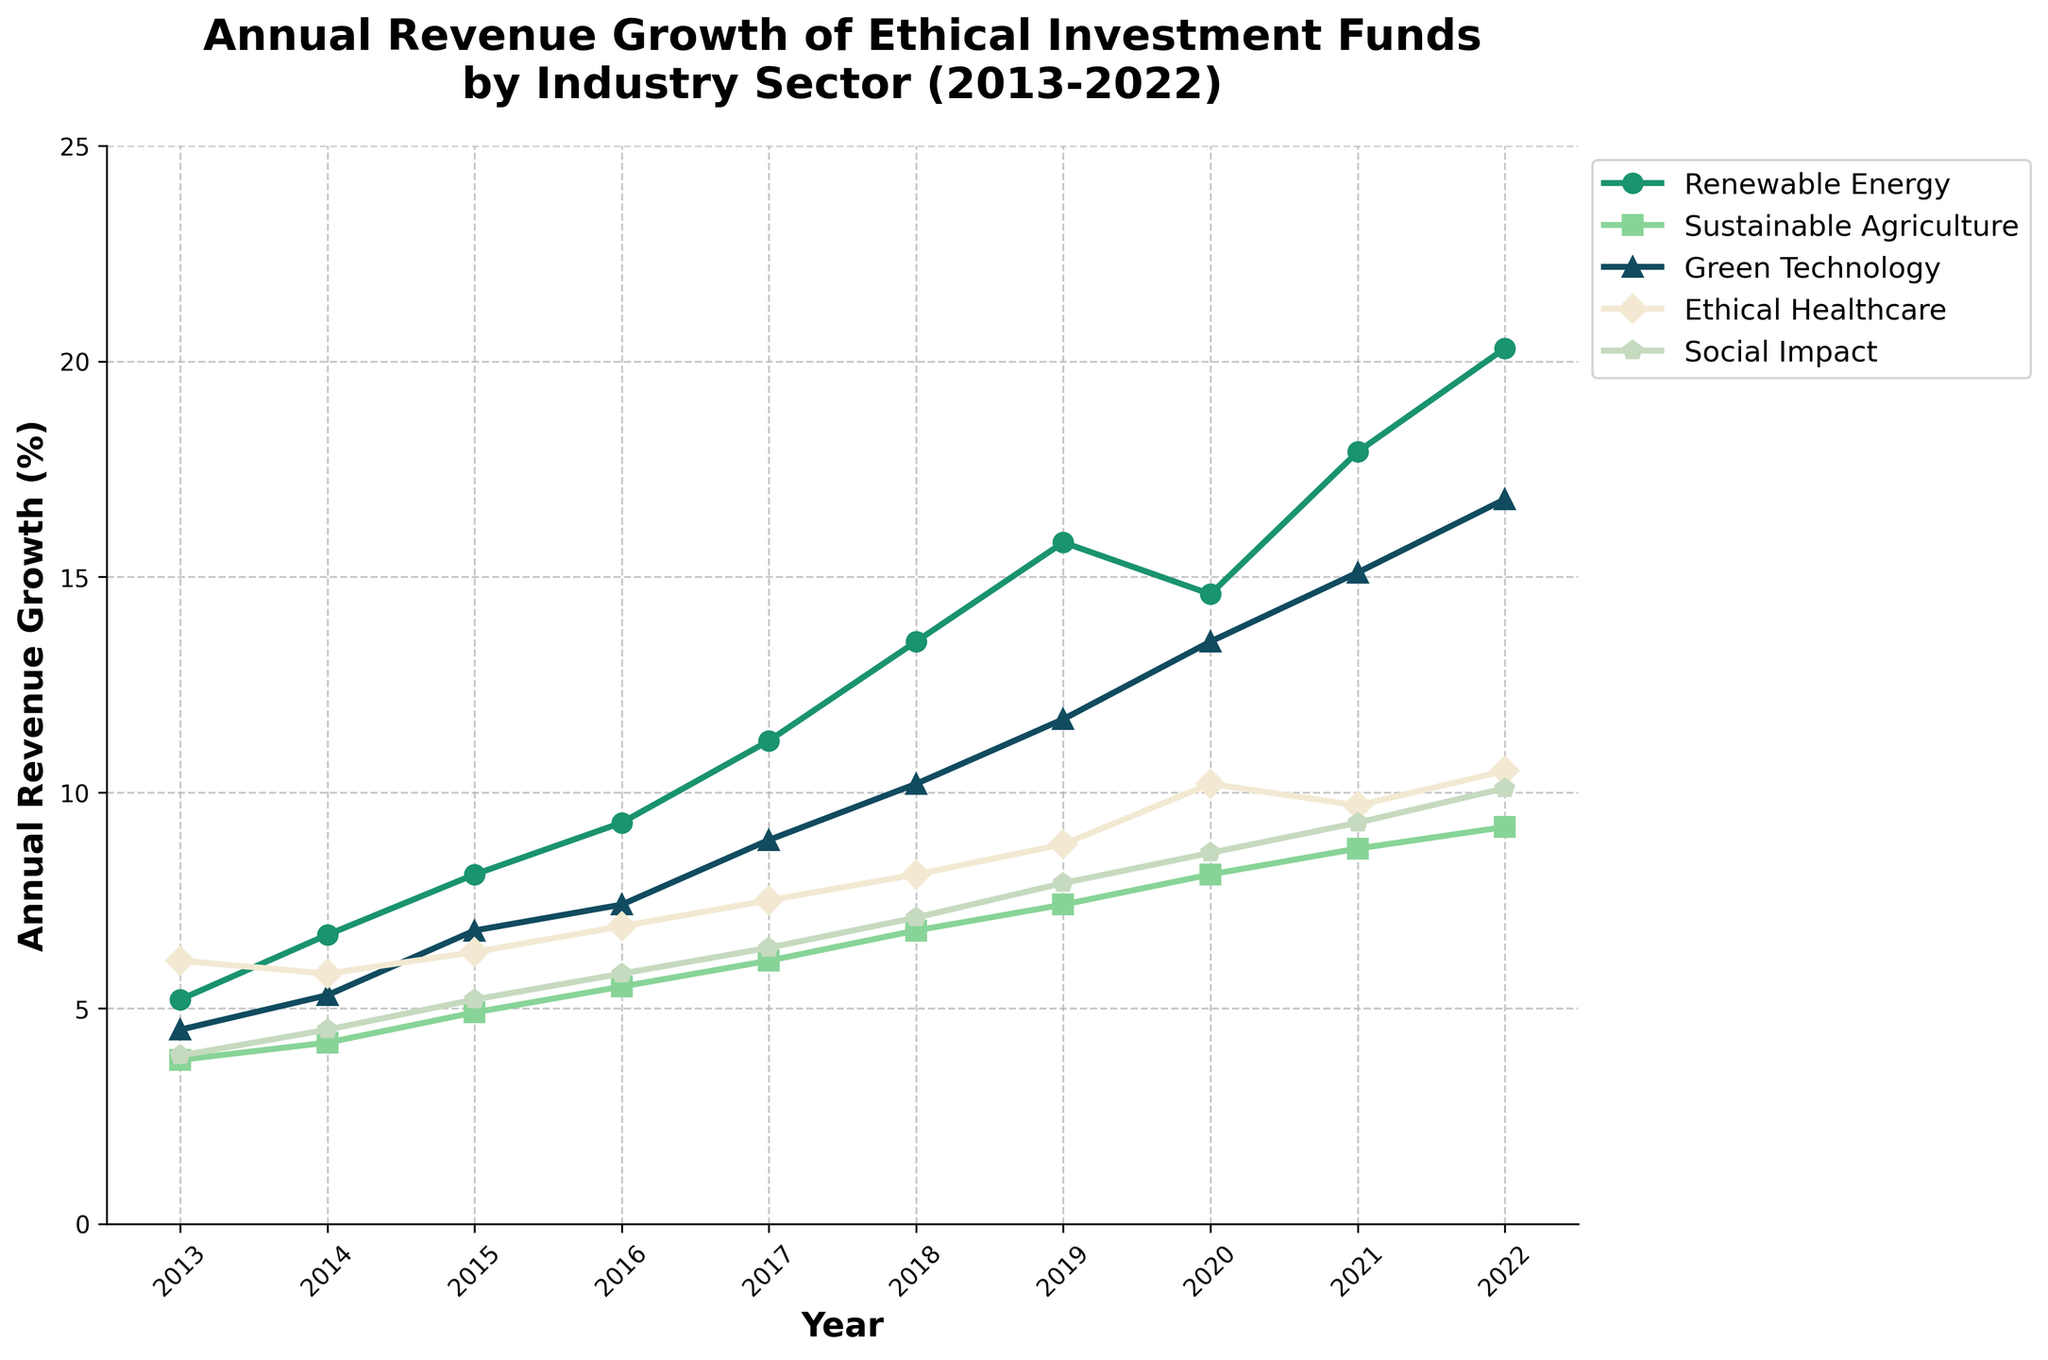What's the overall trend of revenue growth for Renewable Energy from 2013 to 2022? From the figure, the line for Renewable Energy continually rises each year, indicating a strong upward trend in revenue growth.
Answer: Upward trend Which sector had the highest revenue growth in 2022? In 2022, Renewable Energy had the highest point among all sectors on the vertical axis representing revenue growth.
Answer: Renewable Energy Between 2015 and 2016, which sector showed the greatest increase in revenue growth? By observing the slope of the lines between 2015 and 2016, Renewable Energy had the steepest increase. This indicates the greatest rise in revenue growth.
Answer: Renewable Energy How does the revenue growth of Ethical Healthcare in 2017 compare to that in 2022? In 2017, Ethical Healthcare had lower revenue growth compared to 2022. The line for Ethical Healthcare increases across these years.
Answer: Lower in 2017 What is the average revenue growth for Social Impact over the period from 2013 to 2022? Sum the revenue growth percentages for Social Impact from each year and divide by the number of years: (3.9 + 4.5 + 5.2 + 5.8 + 6.4 + 7.1 + 7.9 + 8.6 + 9.3 + 10.1) / 10 = 6.88.
Answer: 6.88% Which sector had comparatively less variability in growth over the observed period? Sustainable Agriculture shows a relatively smoother, less steep line compared to others indicating less variability in revenue growth.
Answer: Sustainable Agriculture Compare the revenue growth of Green Technology in 2018 with Sustainable Agriculture in the same year. In 2018, the figure shows that Green Technology (10.2%) had higher revenue growth than Sustainable Agriculture (6.8%).
Answer: Green Technology higher Did any industry sectors experience a decrease in revenue growth at any point? In 2020, Renewable Energy experienced a slight decrease in revenue growth compared to 2019. The slope of its line declines between these two years.
Answer: Renewable Energy Among all the sectors, which one experienced the highest absolute revenue growth increase from 2013 to 2022? Calculate the difference between 2013 and 2022 for each sector and compare:
- Renewable Energy: 20.3 - 5.2 = 15.1
- Sustainable Agriculture: 9.2 - 3.8 = 5.4
- Green Technology: 16.8 - 4.5 = 12.3
- Ethical Healthcare: 10.5 - 6.1 = 4.4
- Social Impact: 10.1 - 3.9 = 6.2
Hence, Renewable Energy had the highest increase.
Answer: Renewable Energy In which year did Green Technology surpass 10% revenue growth for the first time? The figure shows Green Technology’s revenue growth reaching 10.2% in 2018, which is the first time it surpassed 10%.
Answer: 2018 